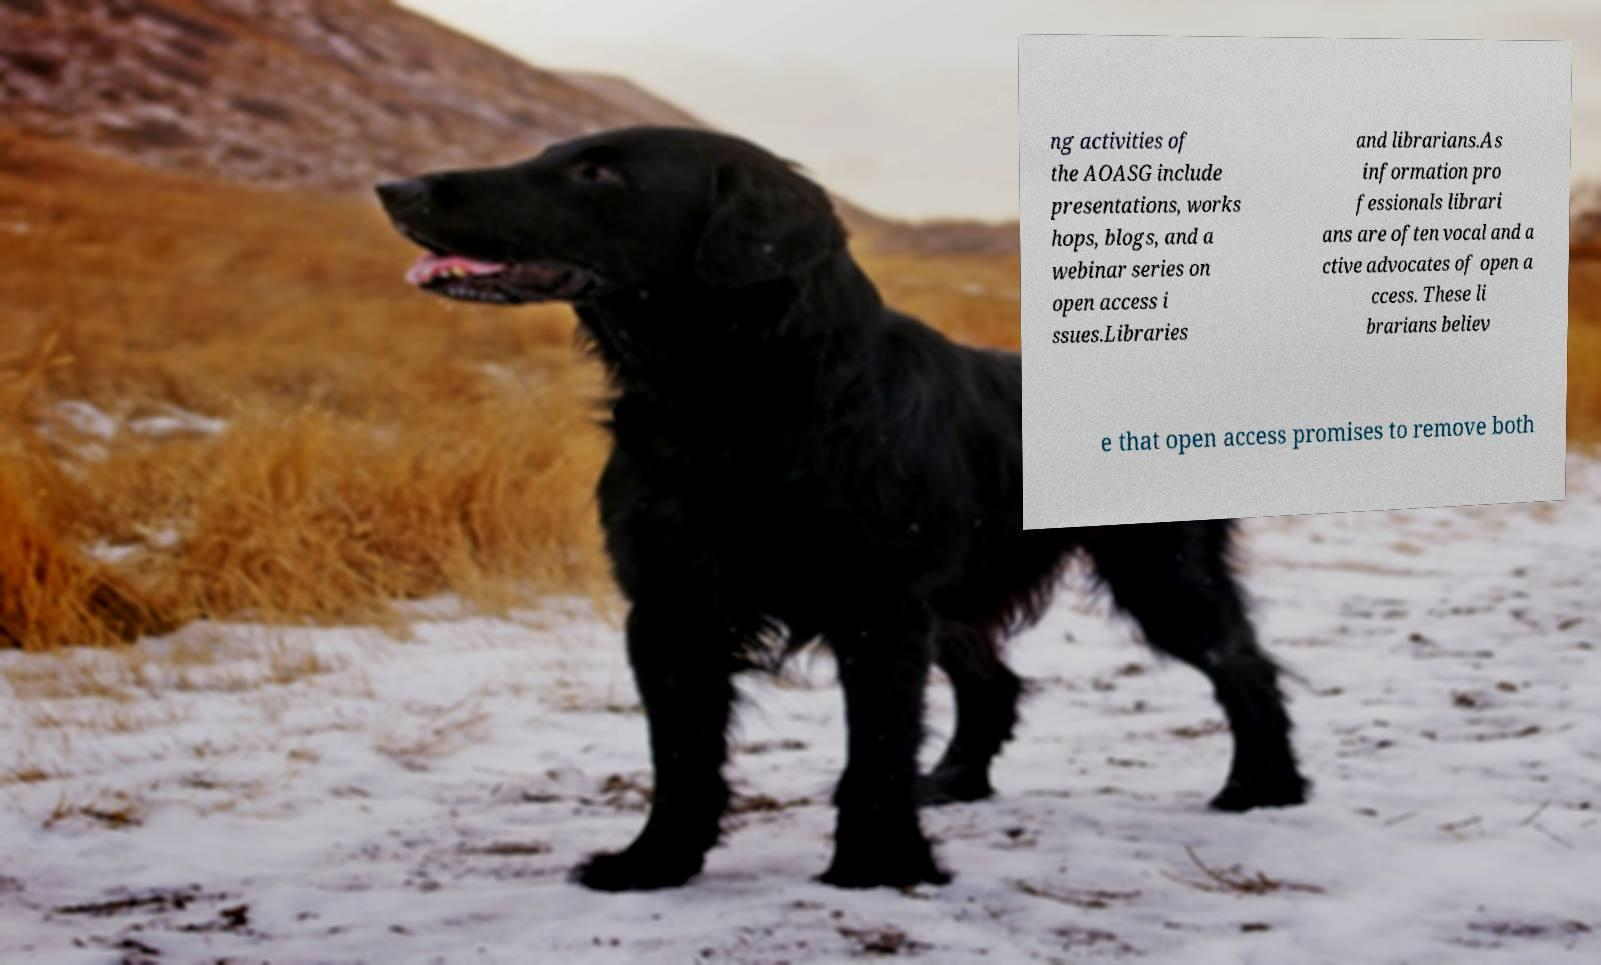Could you extract and type out the text from this image? ng activities of the AOASG include presentations, works hops, blogs, and a webinar series on open access i ssues.Libraries and librarians.As information pro fessionals librari ans are often vocal and a ctive advocates of open a ccess. These li brarians believ e that open access promises to remove both 